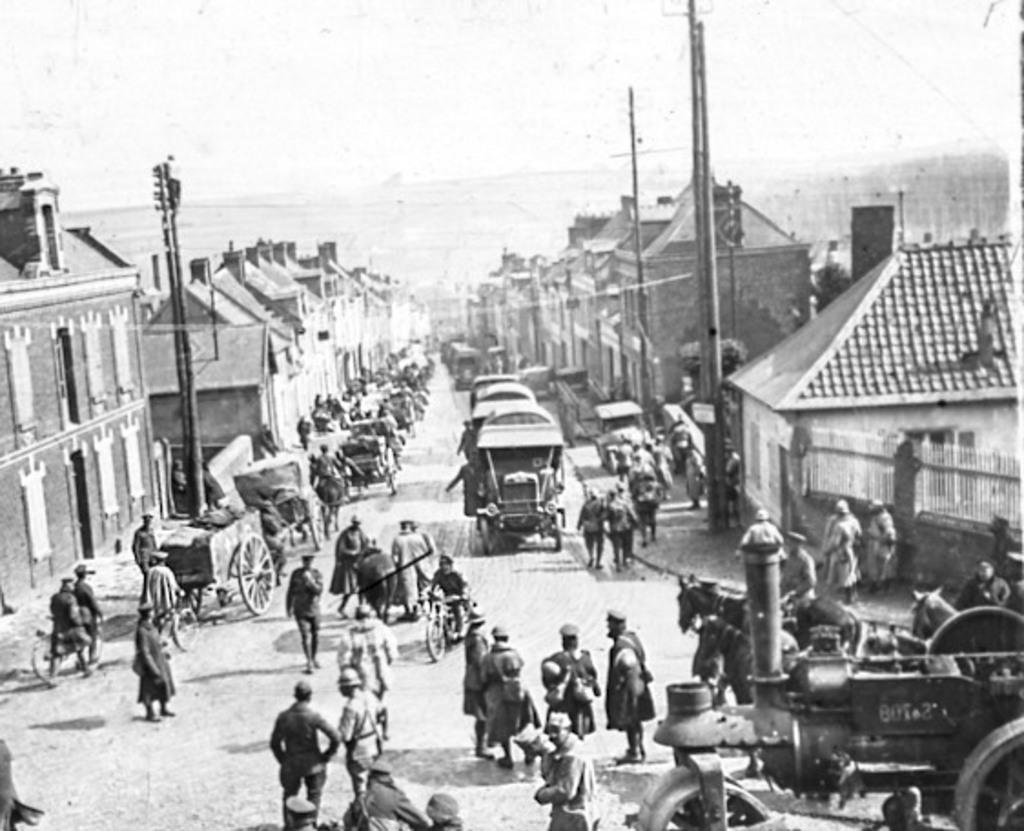Describe this image in one or two sentences. In this picture I can see many people were standing on the road. On the right and left side I can see the building, poles, street lights. At the top I can see the sky. 